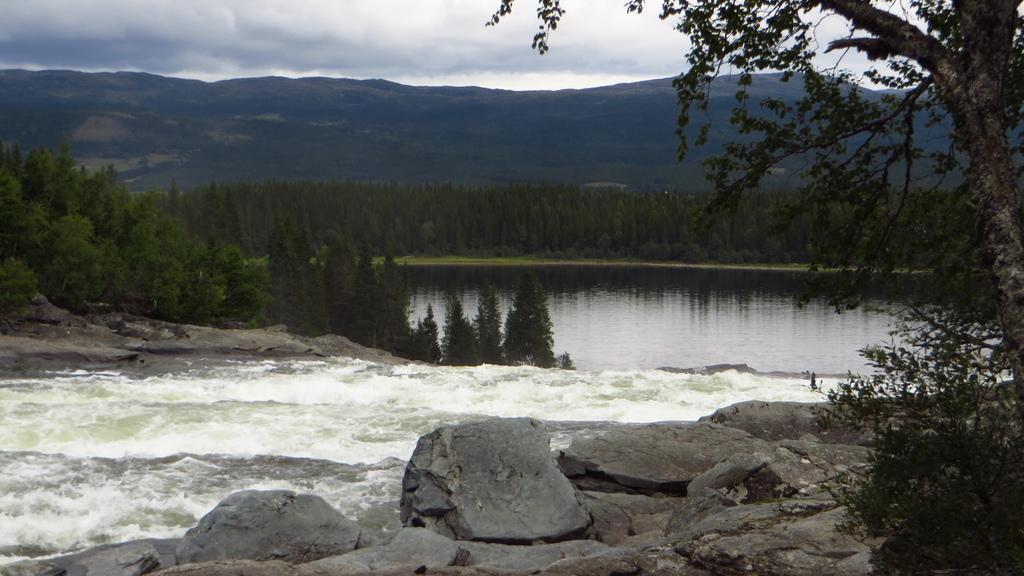Describe this image in one or two sentences. In this picture we can see rocks, trees, mountains, water and in the background we can see the sky with clouds. 